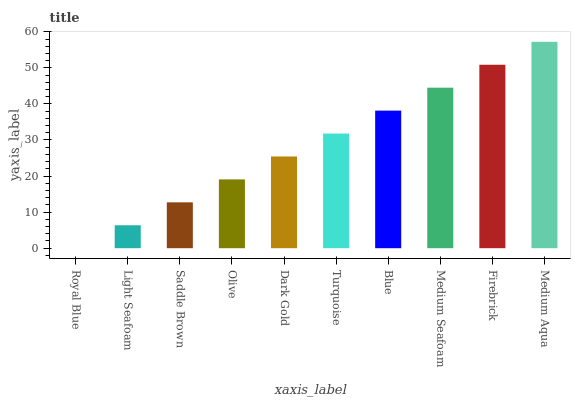Is Light Seafoam the minimum?
Answer yes or no. No. Is Light Seafoam the maximum?
Answer yes or no. No. Is Light Seafoam greater than Royal Blue?
Answer yes or no. Yes. Is Royal Blue less than Light Seafoam?
Answer yes or no. Yes. Is Royal Blue greater than Light Seafoam?
Answer yes or no. No. Is Light Seafoam less than Royal Blue?
Answer yes or no. No. Is Turquoise the high median?
Answer yes or no. Yes. Is Dark Gold the low median?
Answer yes or no. Yes. Is Firebrick the high median?
Answer yes or no. No. Is Medium Seafoam the low median?
Answer yes or no. No. 